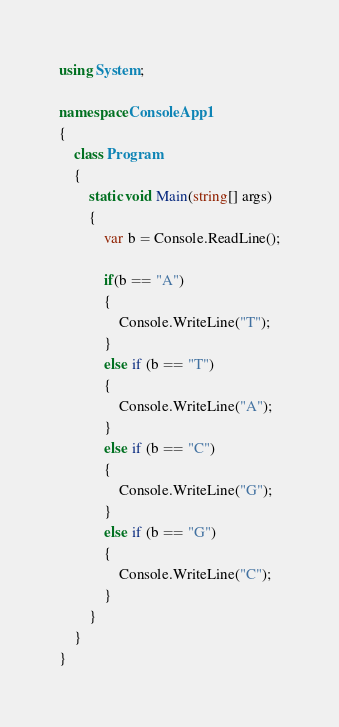Convert code to text. <code><loc_0><loc_0><loc_500><loc_500><_C#_>using System;

namespace ConsoleApp1
{
    class Program
    {
        static void Main(string[] args)
        {
            var b = Console.ReadLine();

            if(b == "A")
            {
                Console.WriteLine("T");
            }
            else if (b == "T")
            {
                Console.WriteLine("A");
            }
            else if (b == "C")
            {
                Console.WriteLine("G");
            }
            else if (b == "G")
            {
                Console.WriteLine("C");
            }
        }
    }
}
</code> 